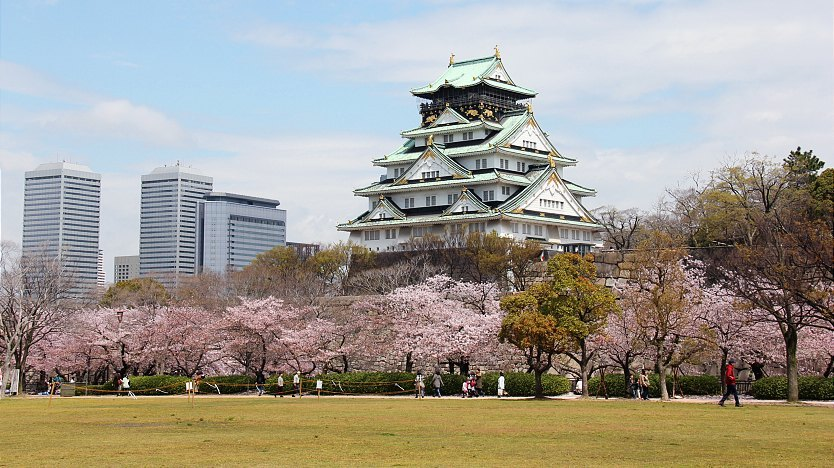Describe the following image. The image showcases the magnificent Osaka Castle, one of Japan's most famous landmarks. This historical structure, with its elegant multi-tiered architecture, stands prominently with pristine white walls and a distinctive green roof adorned with gold embellishments. The surroundings are equally captivating, featuring a sprawling park filled with cherry blossom trees that are in full bloom, their delicate pink petals creating a breathtaking contrast against the sturdy castle. The scene blends the traditional charm of the castle with the modernity of distant skyscrapers, symbolizing the harmonious coexistence of Japan’s rich cultural heritage and contemporary advancements. The soft lighting enhances the serene and picturesque atmosphere, making it a perfect representation of nature's beauty intertwined with architectural grandeur. 